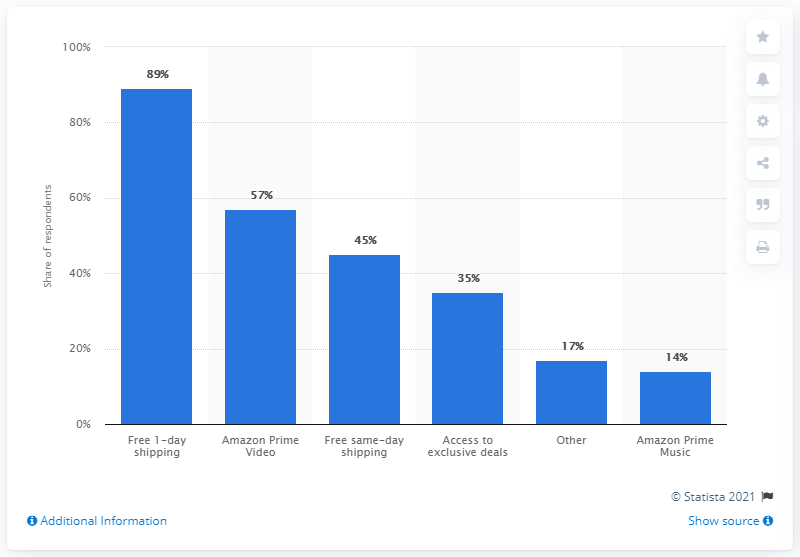List a handful of essential elements in this visual. According to the responses given by the respondents, 57% of them mentioned Amazon Prime video as one of the reasons for subscribing to Amazon Prime. 